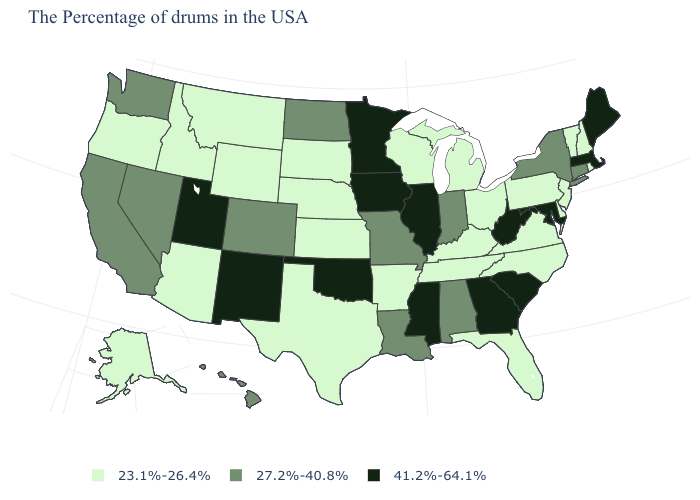Among the states that border Maryland , which have the lowest value?
Quick response, please. Delaware, Pennsylvania, Virginia. What is the value of Texas?
Give a very brief answer. 23.1%-26.4%. Which states have the lowest value in the MidWest?
Be succinct. Ohio, Michigan, Wisconsin, Kansas, Nebraska, South Dakota. Name the states that have a value in the range 23.1%-26.4%?
Quick response, please. Rhode Island, New Hampshire, Vermont, New Jersey, Delaware, Pennsylvania, Virginia, North Carolina, Ohio, Florida, Michigan, Kentucky, Tennessee, Wisconsin, Arkansas, Kansas, Nebraska, Texas, South Dakota, Wyoming, Montana, Arizona, Idaho, Oregon, Alaska. What is the value of Wisconsin?
Answer briefly. 23.1%-26.4%. What is the lowest value in the USA?
Be succinct. 23.1%-26.4%. What is the value of Pennsylvania?
Quick response, please. 23.1%-26.4%. Is the legend a continuous bar?
Write a very short answer. No. What is the lowest value in the MidWest?
Answer briefly. 23.1%-26.4%. Name the states that have a value in the range 41.2%-64.1%?
Write a very short answer. Maine, Massachusetts, Maryland, South Carolina, West Virginia, Georgia, Illinois, Mississippi, Minnesota, Iowa, Oklahoma, New Mexico, Utah. Name the states that have a value in the range 41.2%-64.1%?
Short answer required. Maine, Massachusetts, Maryland, South Carolina, West Virginia, Georgia, Illinois, Mississippi, Minnesota, Iowa, Oklahoma, New Mexico, Utah. What is the value of California?
Answer briefly. 27.2%-40.8%. How many symbols are there in the legend?
Write a very short answer. 3. Name the states that have a value in the range 41.2%-64.1%?
Give a very brief answer. Maine, Massachusetts, Maryland, South Carolina, West Virginia, Georgia, Illinois, Mississippi, Minnesota, Iowa, Oklahoma, New Mexico, Utah. Among the states that border Kansas , which have the lowest value?
Short answer required. Nebraska. 